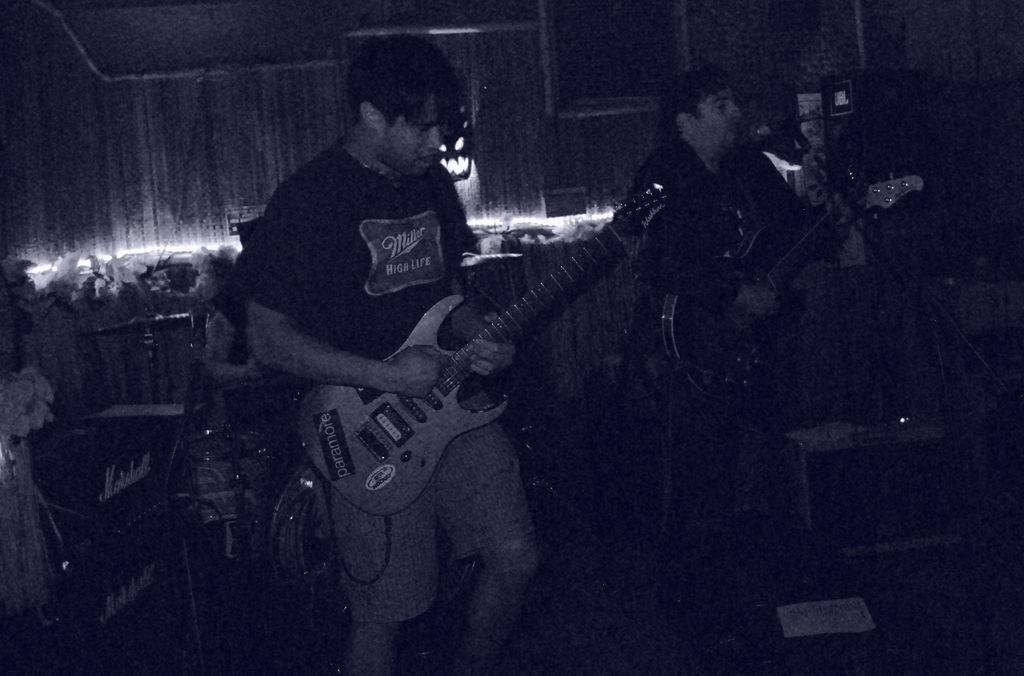How would you summarize this image in a sentence or two? This picture describes about group of people in the left side of the given image a man is playing guitar and another man also playing guitar in front of microphone, in the background we can see couple of flowers and musical instruments. 